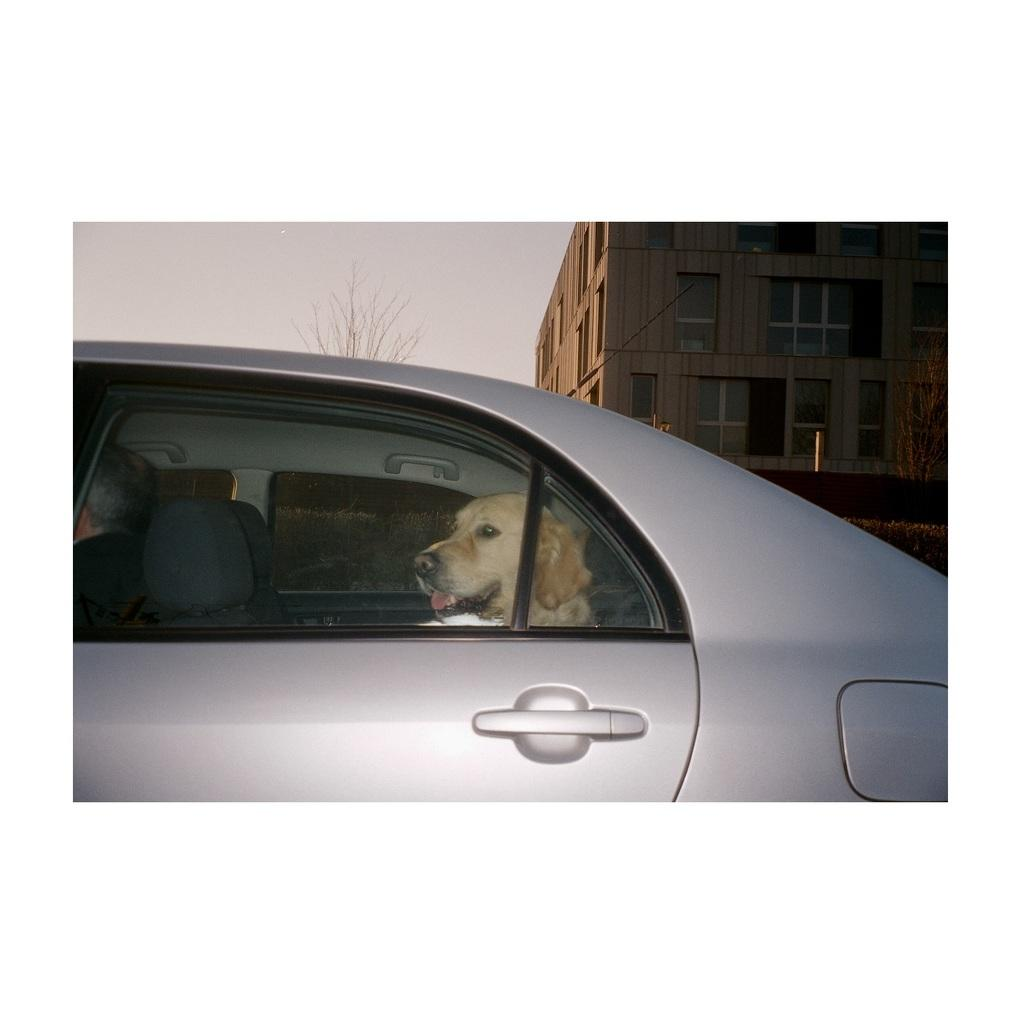What is the main subject of the image? The main subject of the image is a car window. What can be seen through the car window? A dog is inside the car. What is visible in the background of the image? There is a building visible in the background of the image. How many heads does the dog have in the image? The dog has one head in the image. Are there any feet visible in the image? There are no feet visible in the image; only a dog inside a car and a building in the background are present. 